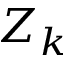Convert formula to latex. <formula><loc_0><loc_0><loc_500><loc_500>Z _ { k }</formula> 